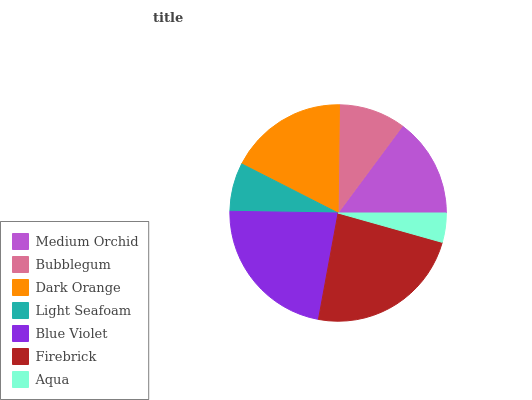Is Aqua the minimum?
Answer yes or no. Yes. Is Firebrick the maximum?
Answer yes or no. Yes. Is Bubblegum the minimum?
Answer yes or no. No. Is Bubblegum the maximum?
Answer yes or no. No. Is Medium Orchid greater than Bubblegum?
Answer yes or no. Yes. Is Bubblegum less than Medium Orchid?
Answer yes or no. Yes. Is Bubblegum greater than Medium Orchid?
Answer yes or no. No. Is Medium Orchid less than Bubblegum?
Answer yes or no. No. Is Medium Orchid the high median?
Answer yes or no. Yes. Is Medium Orchid the low median?
Answer yes or no. Yes. Is Aqua the high median?
Answer yes or no. No. Is Light Seafoam the low median?
Answer yes or no. No. 